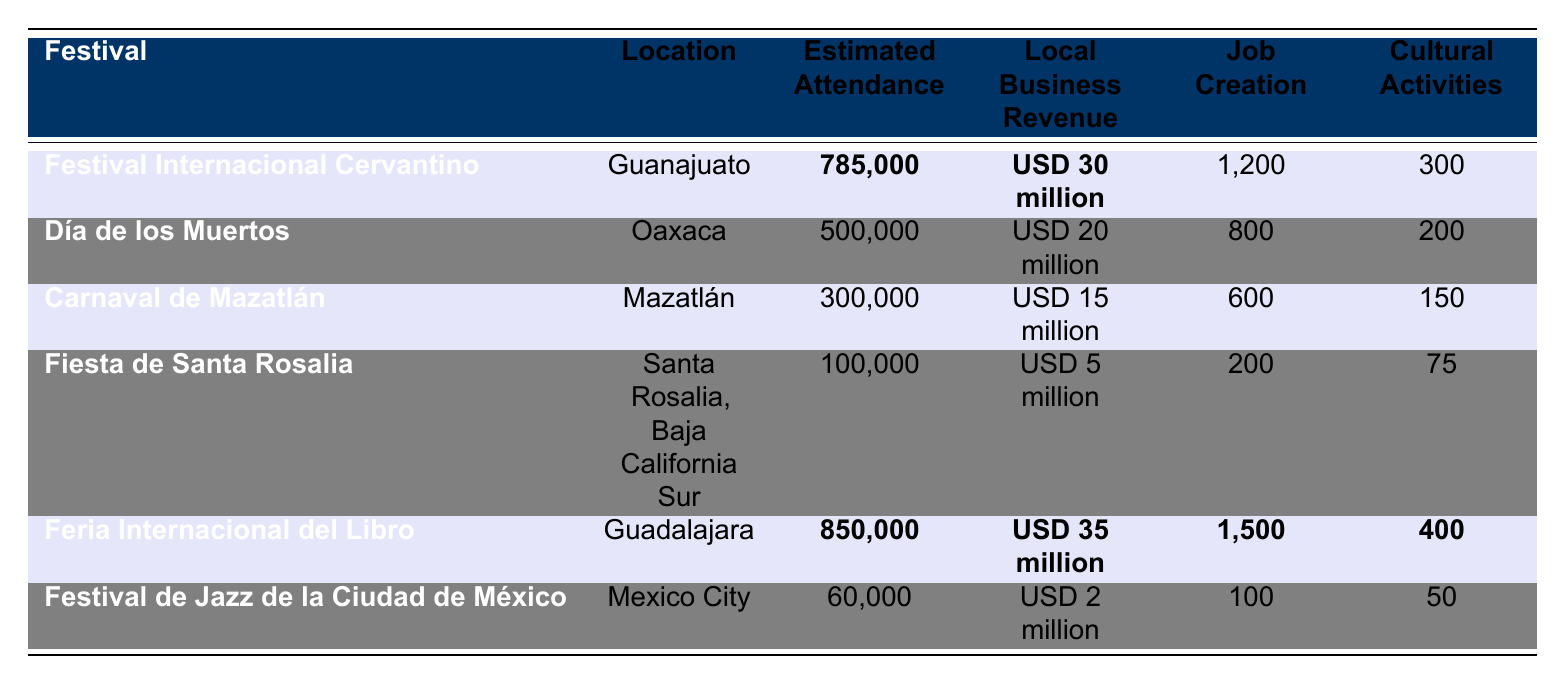What is the estimated attendance for the Feria Internacional del Libro? The table shows the estimated attendance for the Feria Internacional del Libro as 850,000.
Answer: 850,000 Which festival had the highest local business revenue? By comparing the revenue listed for each festival, the Feria Internacional del Libro has the highest local business revenue at USD 35 million.
Answer: Feria Internacional del Libro How many cultural activities were associated with the Festival Internacional Cervantino? The table indicates that the Festival Internacional Cervantino had 300 cultural activities.
Answer: 300 What is the total job creation from the festivals listed? Adding the job creation numbers from each festival gives: 1200 + 800 + 600 + 200 + 1500 + 100 = 3400.
Answer: 3,400 Which festival had the lowest estimated attendance? The table shows that the Festival de Jazz de la Ciudad de México had the lowest estimated attendance at 60,000.
Answer: Festival de Jazz de la Ciudad de México Is the total local business revenue from all festivals more than USD 100 million? The total local business revenue calculated from the table is: USD 30 million + USD 20 million + USD 15 million + USD 5 million + USD 35 million + USD 2 million = USD 107 million, which is more than USD 100 million.
Answer: Yes What percentage of job creation does the Feria Internacional del Libro contribute to the total? The festival contributed 1,500 jobs, and the total job creation is 3,400. Calculating the percentage: (1500/3400) * 100 ≈ 44.12%.
Answer: Approximately 44.12% How does the estimated attendance of Día de los Muertos compare to that of Carnaval de Mazatlán? The estimated attendance for Día de los Muertos is 500,000, while for Carnaval de Mazatlán it is 300,000. Since 500,000 is greater than 300,000, Día de los Muertos has higher attendance.
Answer: Día de los Muertos has higher attendance What is the average local business revenue across all festivals? Summing local business revenues gives: USD 30 million + USD 20 million + USD 15 million + USD 5 million + USD 35 million + USD 2 million = USD 107 million. Dividing by the number of festivals (6) results in an average of approximately USD 17.83 million.
Answer: Approximately USD 17.83 million Which festival had the highest number of cultural activities? Comparing the cultural activities, the Feria Internacional del Libro had the highest at 400.
Answer: Feria Internacional del Libro 